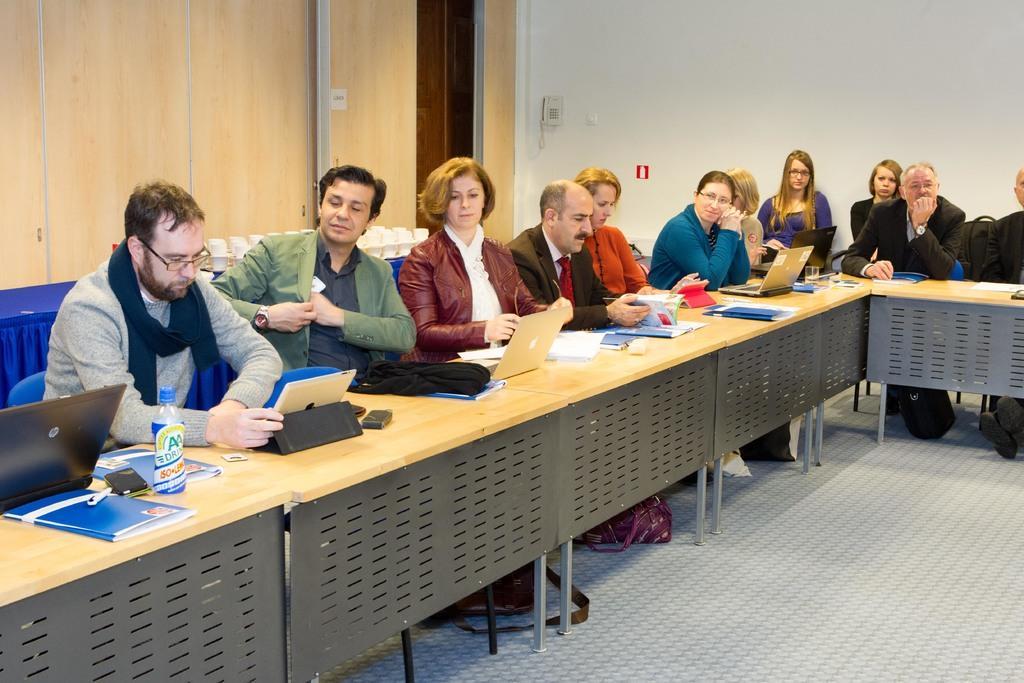In one or two sentences, can you explain what this image depicts? This picture shows a group of people seated on the chairs and we see laptops and few papers, bottles on the table 